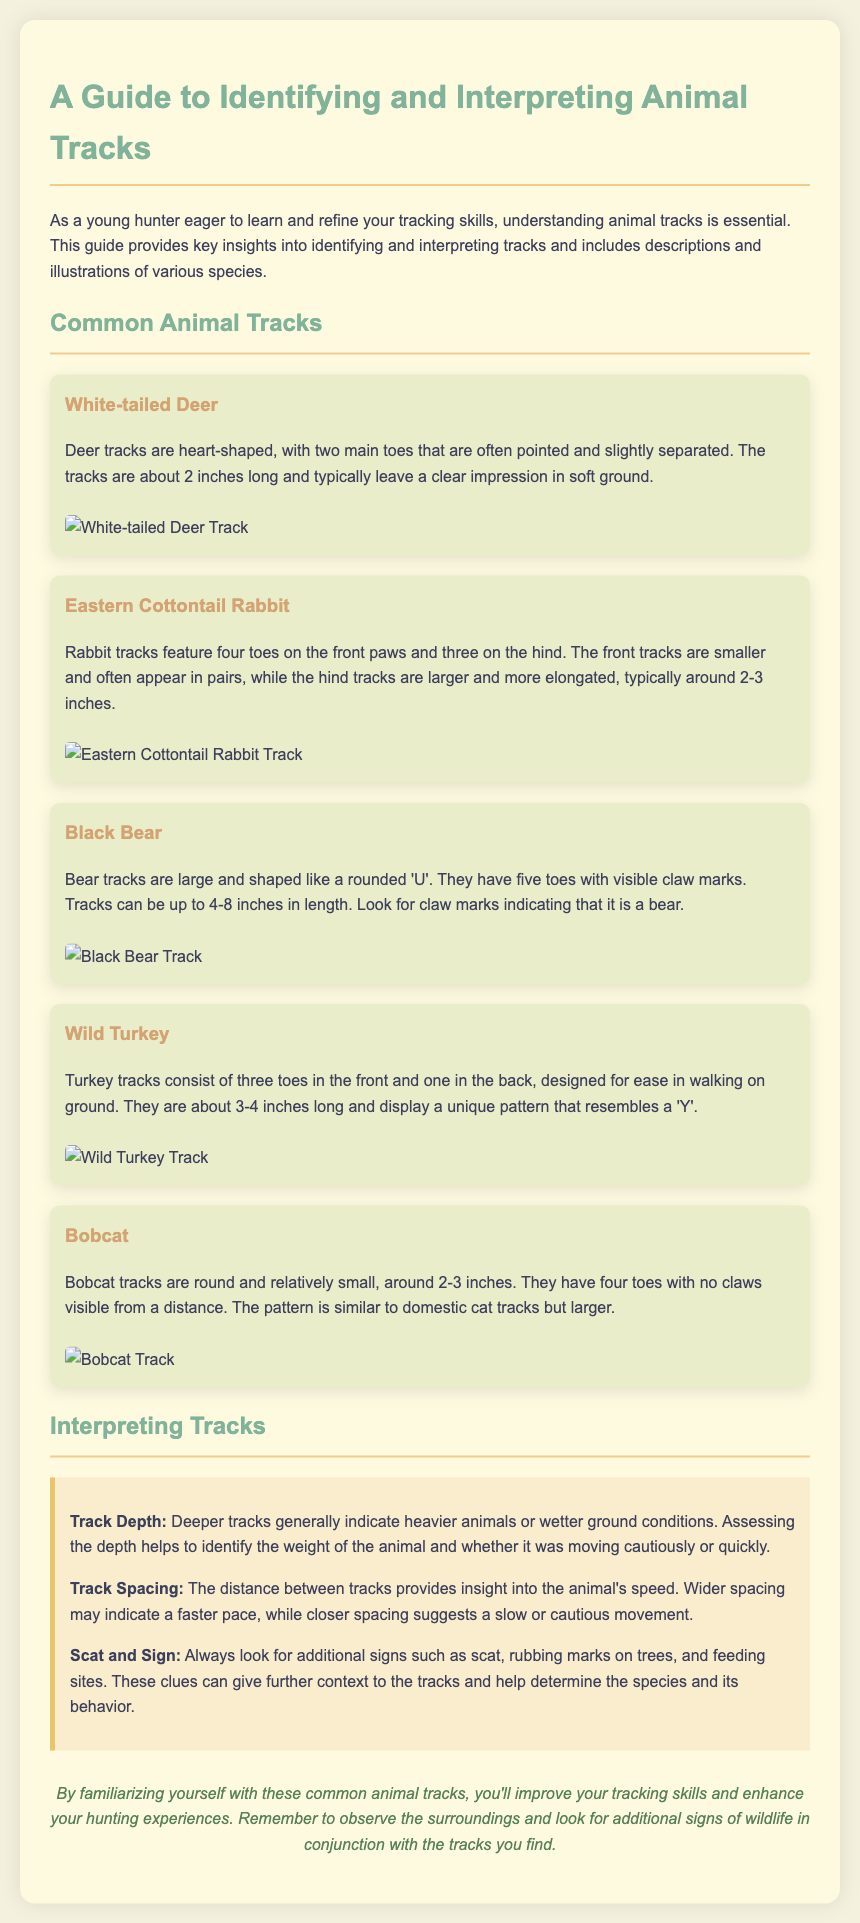what shape are deer tracks? The deer tracks are heart-shaped with two main toes that are pointed and slightly separated.
Answer: heart-shaped how long are bear tracks? The bear tracks can be up to 4-8 inches in length.
Answer: 4-8 inches what unique feature identifies turkey tracks? Turkey tracks consist of three toes in the front and one in the back.
Answer: three toes in the front and one in the back how many toes do rabbit tracks have on the front paws? Rabbit tracks have four toes on the front paws.
Answer: four toes what insight does track spacing provide? Track spacing provides insight into the animal's speed.
Answer: speed what additional signs should be looked for along with tracks? Look for scat, rubbing marks on trees, and feeding sites.
Answer: scat, rubbing marks, feeding sites what is the typical size of bobcat tracks? Bobcat tracks are around 2-3 inches.
Answer: 2-3 inches what does a deeper track generally indicate? A deeper track generally indicates heavier animals or wetter ground conditions.
Answer: heavier animals or wetter ground conditions 